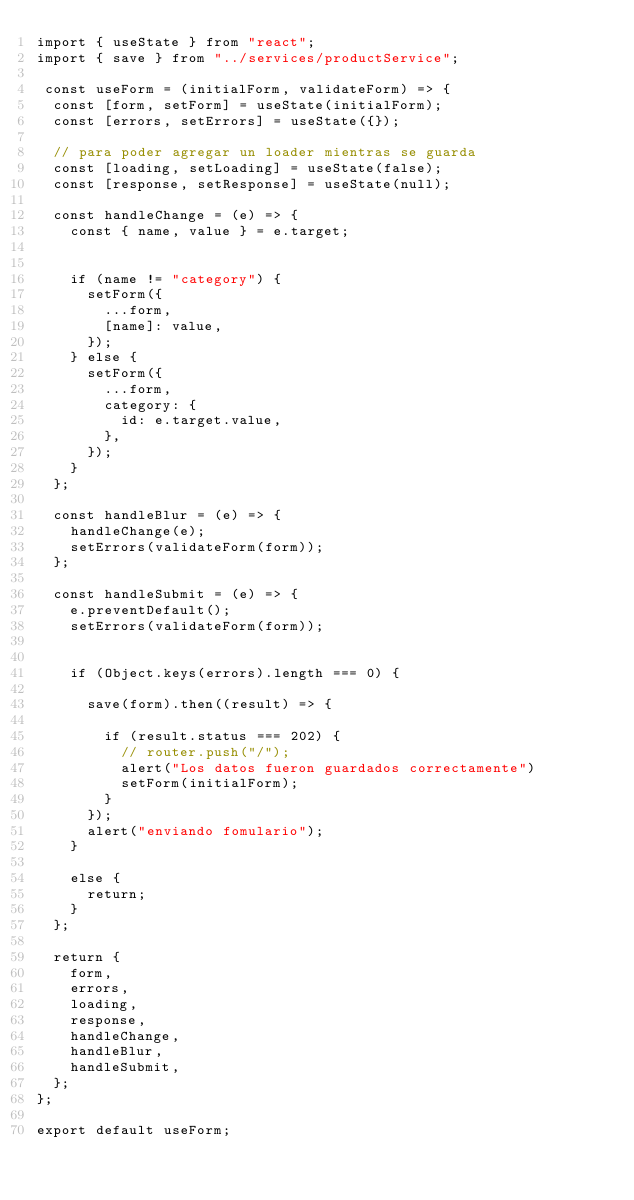Convert code to text. <code><loc_0><loc_0><loc_500><loc_500><_JavaScript_>import { useState } from "react";
import { save } from "../services/productService";

 const useForm = (initialForm, validateForm) => {
  const [form, setForm] = useState(initialForm);
  const [errors, setErrors] = useState({});

  // para poder agregar un loader mientras se guarda
  const [loading, setLoading] = useState(false);
  const [response, setResponse] = useState(null);

  const handleChange = (e) => {
    const { name, value } = e.target;


    if (name != "category") {
      setForm({
        ...form,
        [name]: value,
      });
    } else {
      setForm({
        ...form,
        category: {
          id: e.target.value,
        },
      });
    }
  };

  const handleBlur = (e) => {
    handleChange(e);
    setErrors(validateForm(form));
  };

  const handleSubmit = (e) => {
    e.preventDefault();
    setErrors(validateForm(form));


    if (Object.keys(errors).length === 0) {

      save(form).then((result) => {

        if (result.status === 202) {
          // router.push("/");
          alert("Los datos fueron guardados correctamente")
          setForm(initialForm);
        }
      });
      alert("enviando fomulario");
    } 
    
    else {
      return;
    }
  };

  return {
    form,
    errors,
    loading,
    response,
    handleChange,
    handleBlur,
    handleSubmit,
  };
};

export default useForm;
</code> 